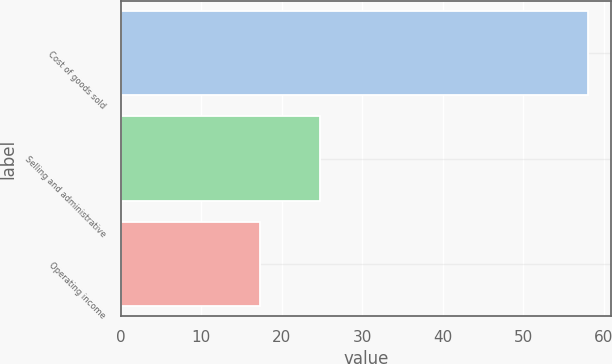<chart> <loc_0><loc_0><loc_500><loc_500><bar_chart><fcel>Cost of goods sold<fcel>Selling and administrative<fcel>Operating income<nl><fcel>58<fcel>24.7<fcel>17.3<nl></chart> 